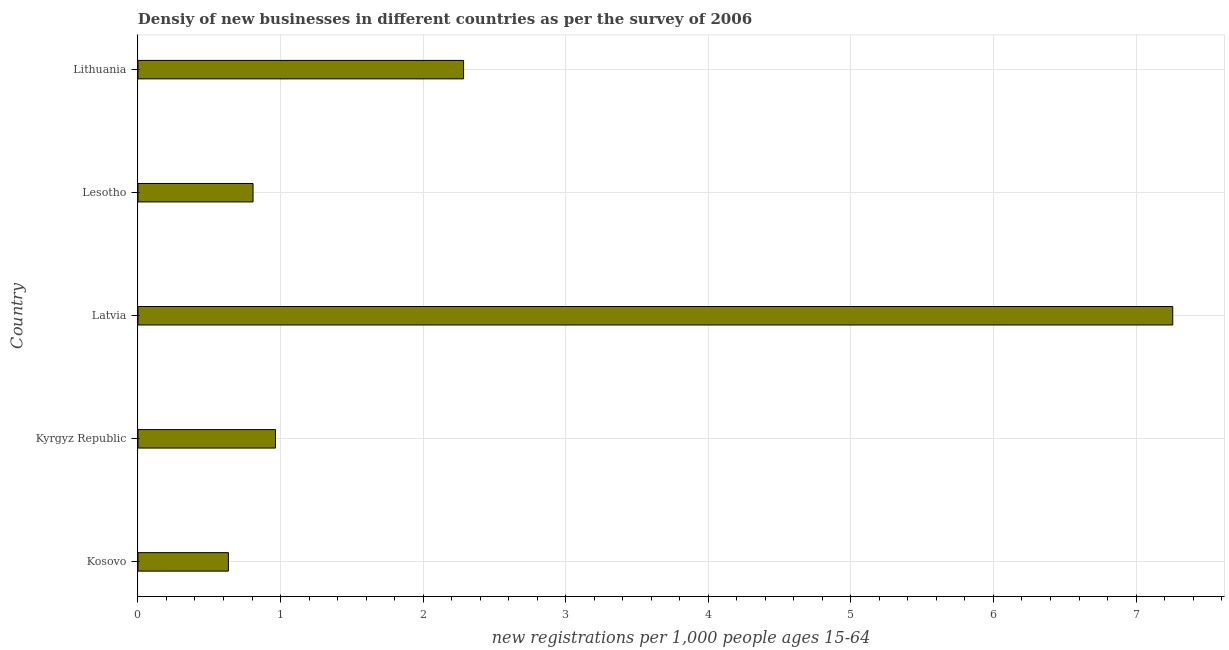Does the graph contain any zero values?
Give a very brief answer. No. Does the graph contain grids?
Ensure brevity in your answer.  Yes. What is the title of the graph?
Provide a short and direct response. Densiy of new businesses in different countries as per the survey of 2006. What is the label or title of the X-axis?
Offer a terse response. New registrations per 1,0 people ages 15-64. What is the density of new business in Lesotho?
Keep it short and to the point. 0.81. Across all countries, what is the maximum density of new business?
Keep it short and to the point. 7.26. Across all countries, what is the minimum density of new business?
Provide a short and direct response. 0.63. In which country was the density of new business maximum?
Your response must be concise. Latvia. In which country was the density of new business minimum?
Your response must be concise. Kosovo. What is the sum of the density of new business?
Your response must be concise. 11.95. What is the difference between the density of new business in Kosovo and Latvia?
Offer a terse response. -6.62. What is the average density of new business per country?
Your response must be concise. 2.39. What is the median density of new business?
Provide a short and direct response. 0.96. What is the ratio of the density of new business in Lesotho to that in Lithuania?
Keep it short and to the point. 0.35. What is the difference between the highest and the second highest density of new business?
Your answer should be compact. 4.97. Is the sum of the density of new business in Kyrgyz Republic and Latvia greater than the maximum density of new business across all countries?
Ensure brevity in your answer.  Yes. What is the difference between the highest and the lowest density of new business?
Ensure brevity in your answer.  6.62. In how many countries, is the density of new business greater than the average density of new business taken over all countries?
Your answer should be very brief. 1. How many bars are there?
Provide a short and direct response. 5. How many countries are there in the graph?
Keep it short and to the point. 5. What is the new registrations per 1,000 people ages 15-64 in Kosovo?
Provide a short and direct response. 0.63. What is the new registrations per 1,000 people ages 15-64 of Kyrgyz Republic?
Offer a very short reply. 0.96. What is the new registrations per 1,000 people ages 15-64 in Latvia?
Your answer should be very brief. 7.26. What is the new registrations per 1,000 people ages 15-64 in Lesotho?
Provide a succinct answer. 0.81. What is the new registrations per 1,000 people ages 15-64 of Lithuania?
Your answer should be very brief. 2.28. What is the difference between the new registrations per 1,000 people ages 15-64 in Kosovo and Kyrgyz Republic?
Offer a very short reply. -0.33. What is the difference between the new registrations per 1,000 people ages 15-64 in Kosovo and Latvia?
Provide a succinct answer. -6.62. What is the difference between the new registrations per 1,000 people ages 15-64 in Kosovo and Lesotho?
Your answer should be very brief. -0.17. What is the difference between the new registrations per 1,000 people ages 15-64 in Kosovo and Lithuania?
Keep it short and to the point. -1.65. What is the difference between the new registrations per 1,000 people ages 15-64 in Kyrgyz Republic and Latvia?
Provide a short and direct response. -6.29. What is the difference between the new registrations per 1,000 people ages 15-64 in Kyrgyz Republic and Lesotho?
Your answer should be compact. 0.16. What is the difference between the new registrations per 1,000 people ages 15-64 in Kyrgyz Republic and Lithuania?
Your answer should be very brief. -1.32. What is the difference between the new registrations per 1,000 people ages 15-64 in Latvia and Lesotho?
Keep it short and to the point. 6.45. What is the difference between the new registrations per 1,000 people ages 15-64 in Latvia and Lithuania?
Make the answer very short. 4.97. What is the difference between the new registrations per 1,000 people ages 15-64 in Lesotho and Lithuania?
Give a very brief answer. -1.48. What is the ratio of the new registrations per 1,000 people ages 15-64 in Kosovo to that in Kyrgyz Republic?
Offer a terse response. 0.66. What is the ratio of the new registrations per 1,000 people ages 15-64 in Kosovo to that in Latvia?
Provide a succinct answer. 0.09. What is the ratio of the new registrations per 1,000 people ages 15-64 in Kosovo to that in Lesotho?
Offer a very short reply. 0.79. What is the ratio of the new registrations per 1,000 people ages 15-64 in Kosovo to that in Lithuania?
Your response must be concise. 0.28. What is the ratio of the new registrations per 1,000 people ages 15-64 in Kyrgyz Republic to that in Latvia?
Your response must be concise. 0.13. What is the ratio of the new registrations per 1,000 people ages 15-64 in Kyrgyz Republic to that in Lesotho?
Ensure brevity in your answer.  1.2. What is the ratio of the new registrations per 1,000 people ages 15-64 in Kyrgyz Republic to that in Lithuania?
Offer a terse response. 0.42. What is the ratio of the new registrations per 1,000 people ages 15-64 in Latvia to that in Lesotho?
Offer a terse response. 8.99. What is the ratio of the new registrations per 1,000 people ages 15-64 in Latvia to that in Lithuania?
Keep it short and to the point. 3.18. What is the ratio of the new registrations per 1,000 people ages 15-64 in Lesotho to that in Lithuania?
Keep it short and to the point. 0.35. 